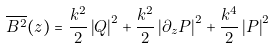<formula> <loc_0><loc_0><loc_500><loc_500>\overline { { B } ^ { 2 } } ( z ) = \frac { k ^ { 2 } } { 2 } \left | Q \right | ^ { 2 } + \frac { k ^ { 2 } } { 2 } \left | \partial _ { z } P \right | ^ { 2 } + \frac { k ^ { 4 } } { 2 } \left | P \right | ^ { 2 }</formula> 